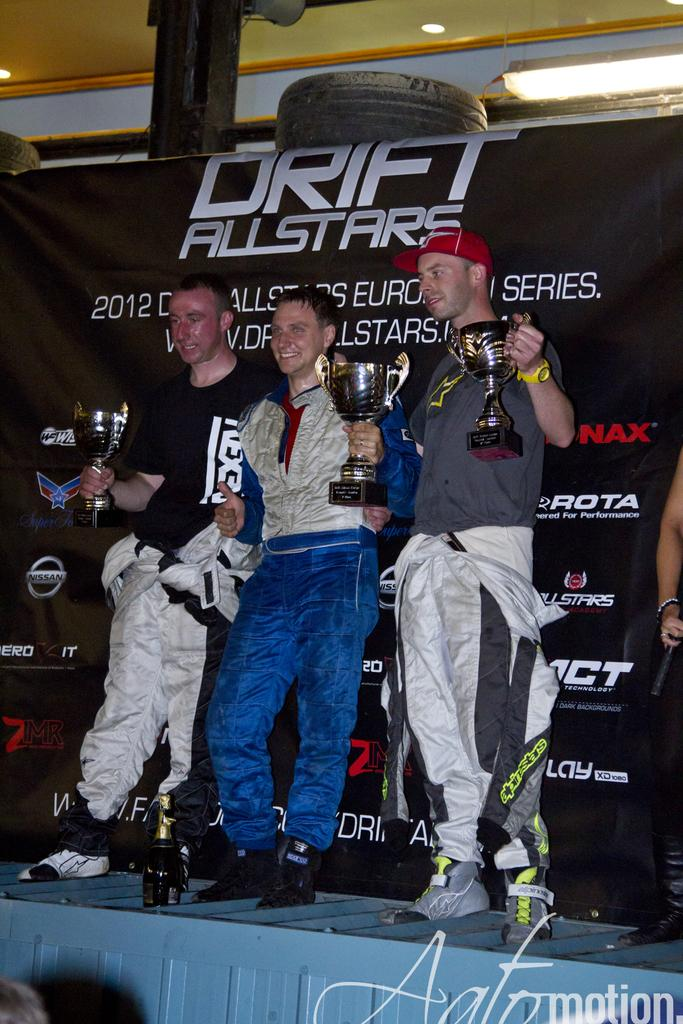<image>
Present a compact description of the photo's key features. three guys holding trophies in front of banner for drift allstars 